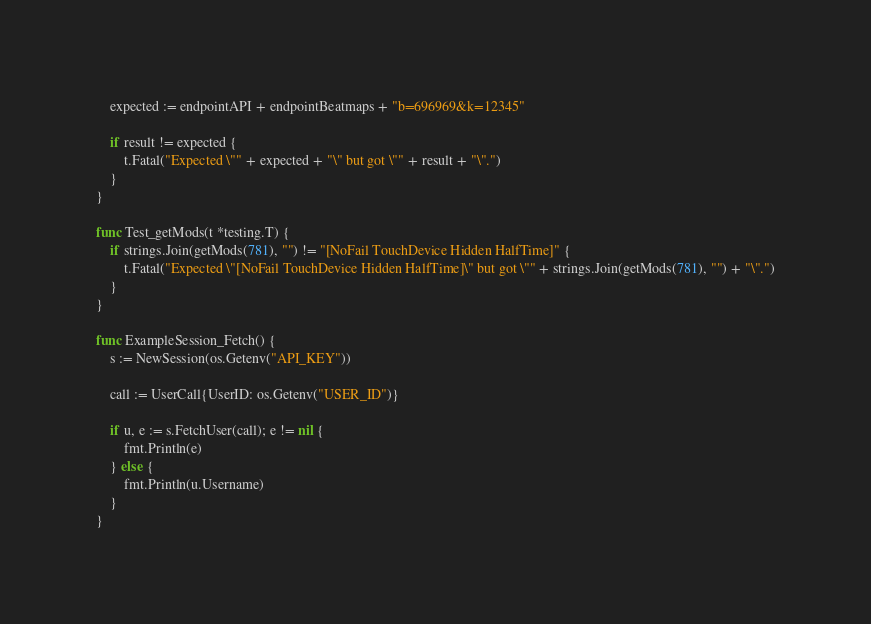<code> <loc_0><loc_0><loc_500><loc_500><_Go_>	expected := endpointAPI + endpointBeatmaps + "b=696969&k=12345"

	if result != expected {
		t.Fatal("Expected \"" + expected + "\" but got \"" + result + "\".")
	}
}

func Test_getMods(t *testing.T) {
	if strings.Join(getMods(781), "") != "[NoFail TouchDevice Hidden HalfTime]" {
		t.Fatal("Expected \"[NoFail TouchDevice Hidden HalfTime]\" but got \"" + strings.Join(getMods(781), "") + "\".")
	}
}

func ExampleSession_Fetch() {
	s := NewSession(os.Getenv("API_KEY"))

	call := UserCall{UserID: os.Getenv("USER_ID")}

	if u, e := s.FetchUser(call); e != nil {
		fmt.Println(e)
	} else {
		fmt.Println(u.Username)
	}
}
</code> 